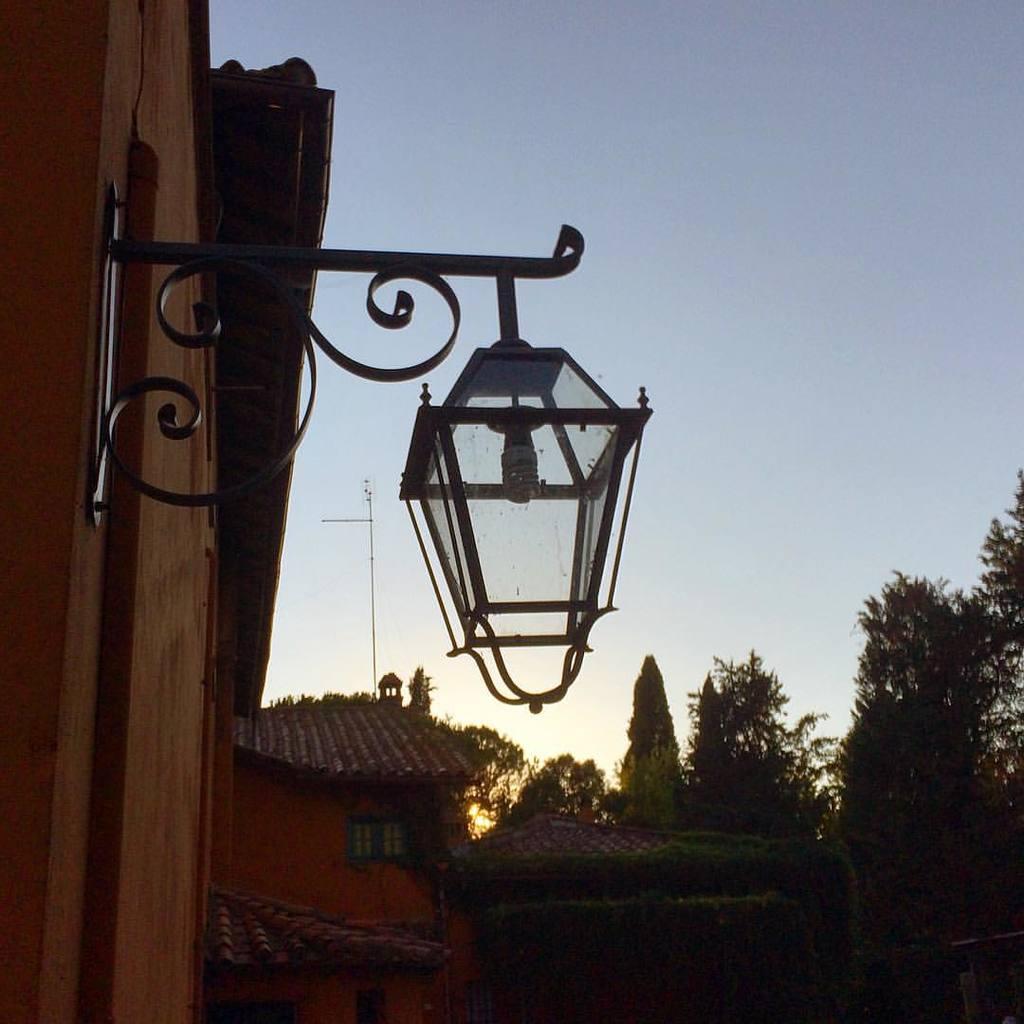In one or two sentences, can you explain what this image depicts? It is a lamp in the middle of an image, on the right side there are green trees, at the top it's a sky. 